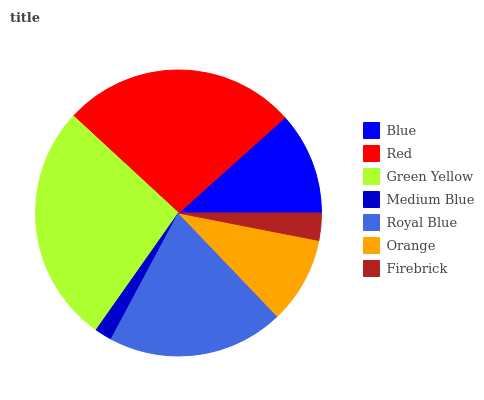Is Medium Blue the minimum?
Answer yes or no. Yes. Is Green Yellow the maximum?
Answer yes or no. Yes. Is Red the minimum?
Answer yes or no. No. Is Red the maximum?
Answer yes or no. No. Is Red greater than Blue?
Answer yes or no. Yes. Is Blue less than Red?
Answer yes or no. Yes. Is Blue greater than Red?
Answer yes or no. No. Is Red less than Blue?
Answer yes or no. No. Is Blue the high median?
Answer yes or no. Yes. Is Blue the low median?
Answer yes or no. Yes. Is Royal Blue the high median?
Answer yes or no. No. Is Royal Blue the low median?
Answer yes or no. No. 